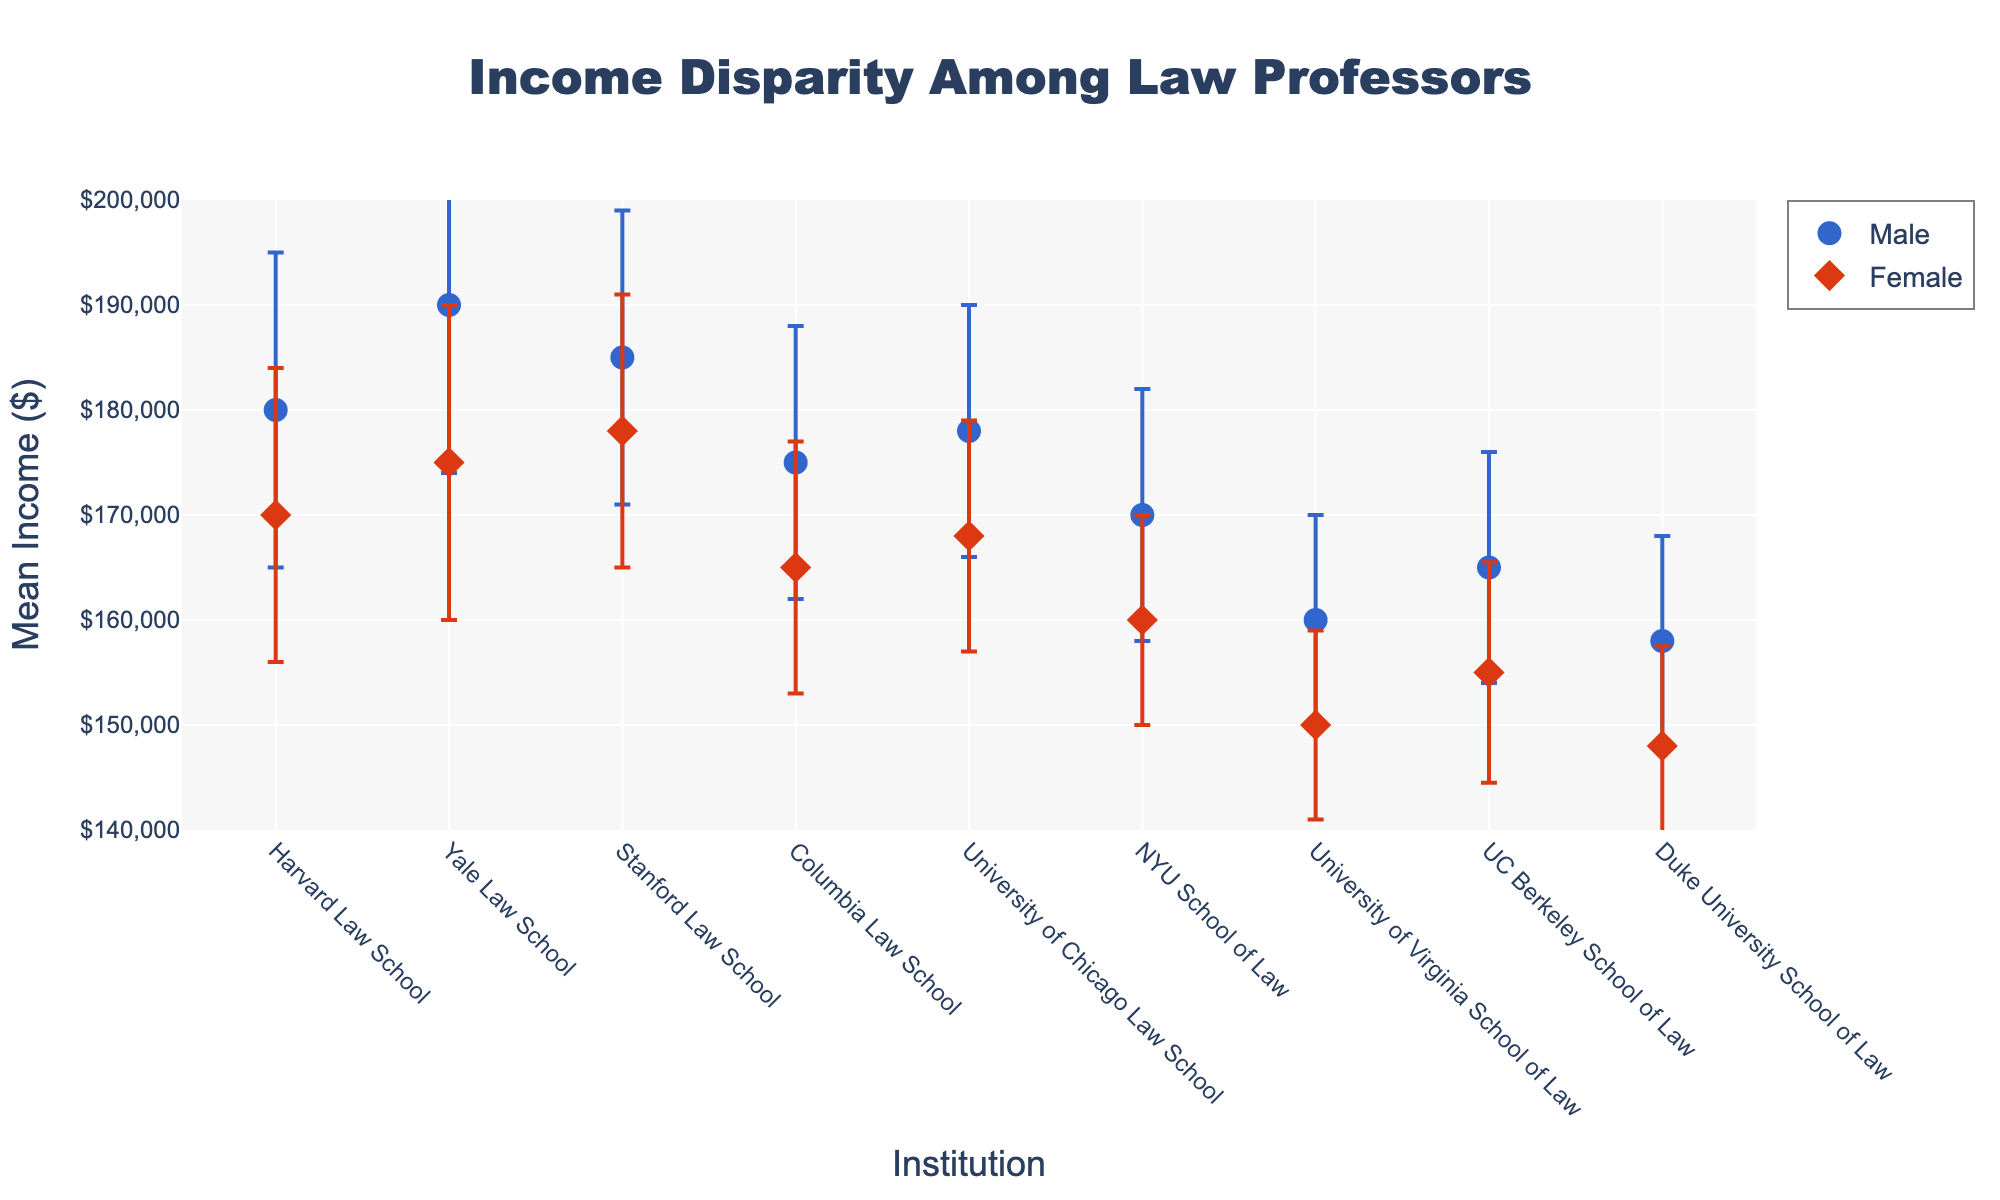How many institutions are displayed on the scatter plot? Count the number of different institutions shown along the x-axis. There are eight: Harvard, Yale, Stanford, Columbia, University of Chicago, NYU, University of Virginia, UC Berkeley, Duke
Answer: Eight What is the income range visualized on the y-axis? Check the minimum and maximum values indicated on the y-axis of the plot. The range is from $140,000 to $200,000.
Answer: $140,000 to $200,000 Which institution has the highest mean income for female law professors? Identify the data point for the highest y-value among female law professors. Yale Law School has the highest mean income for female professors at $175,000.
Answer: Yale Law School What is the income disparity between male and female law professors at Harvard Law School? Find the mean income for both male and female law professors at Harvard Law School and subtract the female mean from the male mean: $180,000 - $170,000.
Answer: $10,000 Which gender has a larger standard deviation in incomes at Stanford Law School? Compare the standard deviation error bars for male and female data points for Stanford Law School. Males have a standard deviation of $14,000, and females have a standard deviation of $13,000. Therefore, males have the larger standard deviation.
Answer: Males At which institution is the standard deviation in mean income for females the highest? Look at the size of the error bars for female law professors across all institutions. Yale Law School had the largest error bar for females at $15,000.
Answer: Yale Law School How does the mean income of female professors at NYU School of Law compare to the mean income of female professors at Duke University School of Law? Compare the y-values (mean incomes) for female professors at these two institutions. NYU has $160,000, while Duke has $148,000.
Answer: NYU is higher What is the difference in mean income between the highest-paid male law professors and the lowest-paid male law professors? Identify the highest and lowest mean income values among male professors. Yale Law School has the highest at $190,000, and Duke University has the lowest at $158,000. Subtract the two: $190,000 - $158,000.
Answer: $32,000 Which institutions have a mean income gap of $10,000 or less between male and female law professors? Calculate the absolute difference in mean income between male and female law professors at each institution. Check for differences of $10,000 or less. Harvard ($10,000), Stanford ($7,000), University of Chicago ($10,000) meet this criterion.
Answer: Harvard, Stanford, University of Chicago 